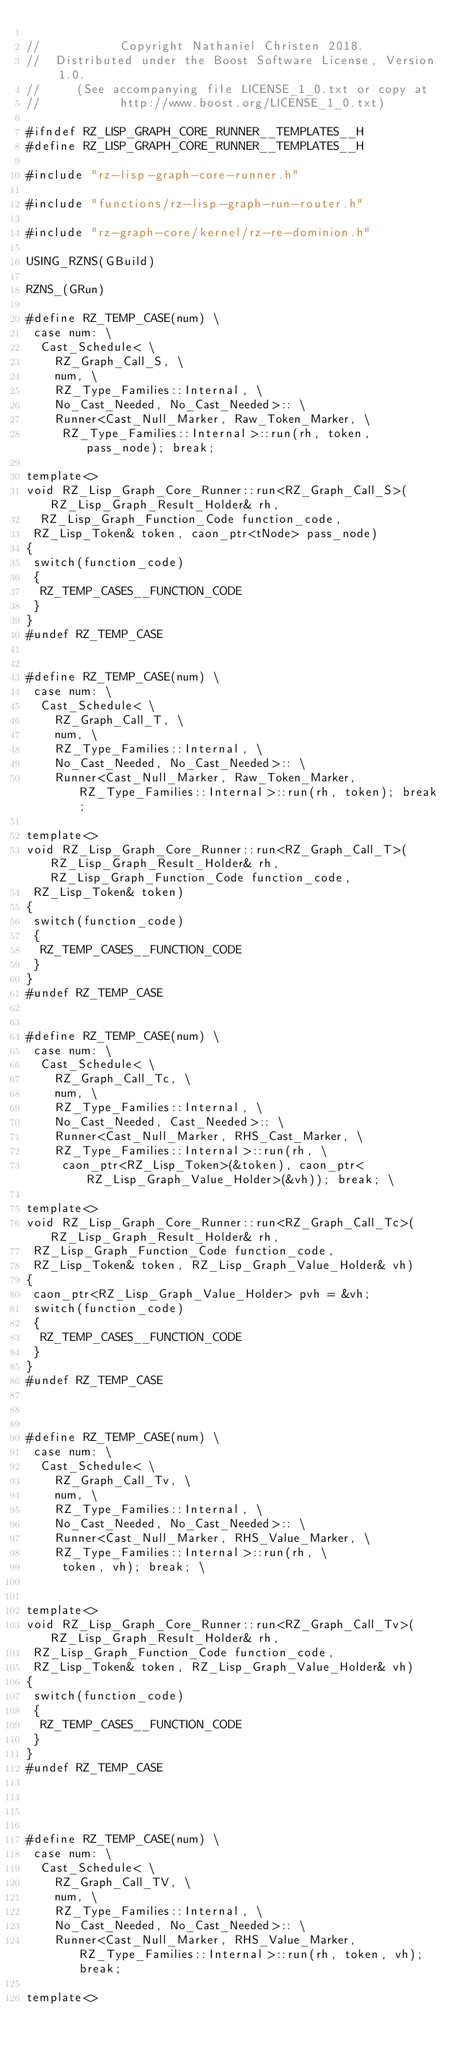<code> <loc_0><loc_0><loc_500><loc_500><_C_>
//           Copyright Nathaniel Christen 2018.
//  Distributed under the Boost Software License, Version 1.0.
//     (See accompanying file LICENSE_1_0.txt or copy at
//           http://www.boost.org/LICENSE_1_0.txt)

#ifndef RZ_LISP_GRAPH_CORE_RUNNER__TEMPLATES__H
#define RZ_LISP_GRAPH_CORE_RUNNER__TEMPLATES__H

#include "rz-lisp-graph-core-runner.h"

#include "functions/rz-lisp-graph-run-router.h"

#include "rz-graph-core/kernel/rz-re-dominion.h"

USING_RZNS(GBuild)

RZNS_(GRun)

#define RZ_TEMP_CASE(num) \
 case num: \
  Cast_Schedule< \
    RZ_Graph_Call_S, \
    num, \
    RZ_Type_Families::Internal, \
    No_Cast_Needed, No_Cast_Needed>:: \
    Runner<Cast_Null_Marker, Raw_Token_Marker, \
     RZ_Type_Families::Internal>::run(rh, token, pass_node); break;

template<>
void RZ_Lisp_Graph_Core_Runner::run<RZ_Graph_Call_S>(RZ_Lisp_Graph_Result_Holder& rh,
  RZ_Lisp_Graph_Function_Code function_code,
 RZ_Lisp_Token& token, caon_ptr<tNode> pass_node)
{
 switch(function_code)
 {
  RZ_TEMP_CASES__FUNCTION_CODE
 }
}
#undef RZ_TEMP_CASE


#define RZ_TEMP_CASE(num) \
 case num: \
  Cast_Schedule< \
    RZ_Graph_Call_T, \
    num, \
    RZ_Type_Families::Internal, \
    No_Cast_Needed, No_Cast_Needed>:: \
    Runner<Cast_Null_Marker, Raw_Token_Marker, RZ_Type_Families::Internal>::run(rh, token); break;

template<>
void RZ_Lisp_Graph_Core_Runner::run<RZ_Graph_Call_T>(RZ_Lisp_Graph_Result_Holder& rh, RZ_Lisp_Graph_Function_Code function_code,
 RZ_Lisp_Token& token)
{
 switch(function_code)
 {
  RZ_TEMP_CASES__FUNCTION_CODE
 }
}
#undef RZ_TEMP_CASE


#define RZ_TEMP_CASE(num) \
 case num: \
  Cast_Schedule< \
    RZ_Graph_Call_Tc, \
    num, \
    RZ_Type_Families::Internal, \
    No_Cast_Needed, Cast_Needed>:: \
    Runner<Cast_Null_Marker, RHS_Cast_Marker, \
    RZ_Type_Families::Internal>::run(rh, \
     caon_ptr<RZ_Lisp_Token>(&token), caon_ptr<RZ_Lisp_Graph_Value_Holder>(&vh)); break; \

template<>
void RZ_Lisp_Graph_Core_Runner::run<RZ_Graph_Call_Tc>(RZ_Lisp_Graph_Result_Holder& rh,
 RZ_Lisp_Graph_Function_Code function_code,
 RZ_Lisp_Token& token, RZ_Lisp_Graph_Value_Holder& vh)
{
 caon_ptr<RZ_Lisp_Graph_Value_Holder> pvh = &vh;
 switch(function_code)
 {
  RZ_TEMP_CASES__FUNCTION_CODE
 }
}
#undef RZ_TEMP_CASE



#define RZ_TEMP_CASE(num) \
 case num: \
  Cast_Schedule< \
    RZ_Graph_Call_Tv, \
    num, \
    RZ_Type_Families::Internal, \
    No_Cast_Needed, No_Cast_Needed>:: \
    Runner<Cast_Null_Marker, RHS_Value_Marker, \
    RZ_Type_Families::Internal>::run(rh, \
     token, vh); break; \


template<>
void RZ_Lisp_Graph_Core_Runner::run<RZ_Graph_Call_Tv>(RZ_Lisp_Graph_Result_Holder& rh,
 RZ_Lisp_Graph_Function_Code function_code,
 RZ_Lisp_Token& token, RZ_Lisp_Graph_Value_Holder& vh)
{
 switch(function_code)
 {
  RZ_TEMP_CASES__FUNCTION_CODE
 }
}
#undef RZ_TEMP_CASE




#define RZ_TEMP_CASE(num) \
 case num: \
  Cast_Schedule< \
    RZ_Graph_Call_TV, \
    num, \
    RZ_Type_Families::Internal, \
    No_Cast_Needed, No_Cast_Needed>:: \
    Runner<Cast_Null_Marker, RHS_Value_Marker, RZ_Type_Families::Internal>::run(rh, token, vh); break;

template<></code> 